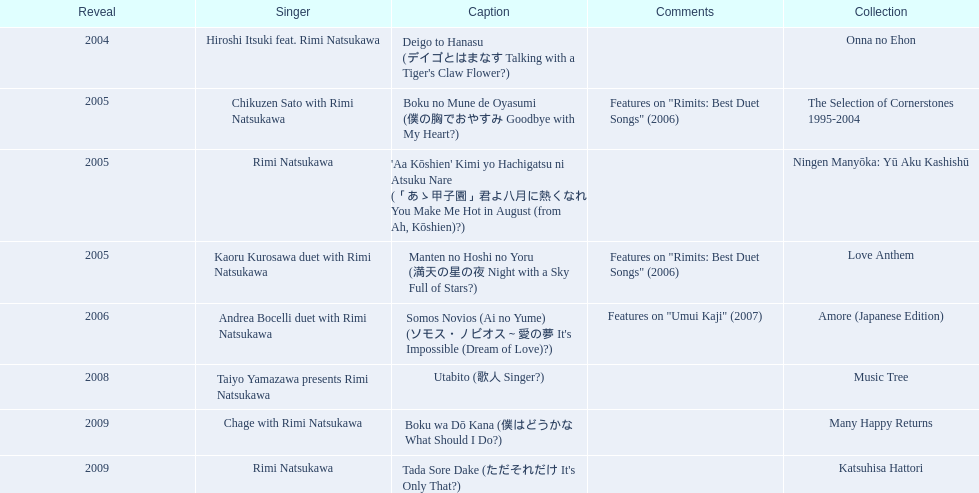What are all of the titles? Deigo to Hanasu (デイゴとはまなす Talking with a Tiger's Claw Flower?), Boku no Mune de Oyasumi (僕の胸でおやすみ Goodbye with My Heart?), 'Aa Kōshien' Kimi yo Hachigatsu ni Atsuku Nare (「あゝ甲子園」君よ八月に熱くなれ You Make Me Hot in August (from Ah, Kōshien)?), Manten no Hoshi no Yoru (満天の星の夜 Night with a Sky Full of Stars?), Somos Novios (Ai no Yume) (ソモス・ノビオス～愛の夢 It's Impossible (Dream of Love)?), Utabito (歌人 Singer?), Boku wa Dō Kana (僕はどうかな What Should I Do?), Tada Sore Dake (ただそれだけ It's Only That?). What are their notes? , Features on "Rimits: Best Duet Songs" (2006), , Features on "Rimits: Best Duet Songs" (2006), Features on "Umui Kaji" (2007), , , . Which title shares its notes with manten no hoshi no yoru (man tian noxing noye night with a sky full of stars?)? Boku no Mune de Oyasumi (僕の胸でおやすみ Goodbye with My Heart?). 